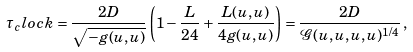Convert formula to latex. <formula><loc_0><loc_0><loc_500><loc_500>\tau _ { c } l o c k = \frac { 2 D } { \sqrt { - g ( u , u ) } } \left ( 1 - \frac { L } { 2 4 } + \frac { L ( u , u ) } { 4 g ( u , u ) } \right ) = \frac { 2 D } { \mathcal { G } ( u , u , u , u ) ^ { 1 / 4 } } \, ,</formula> 